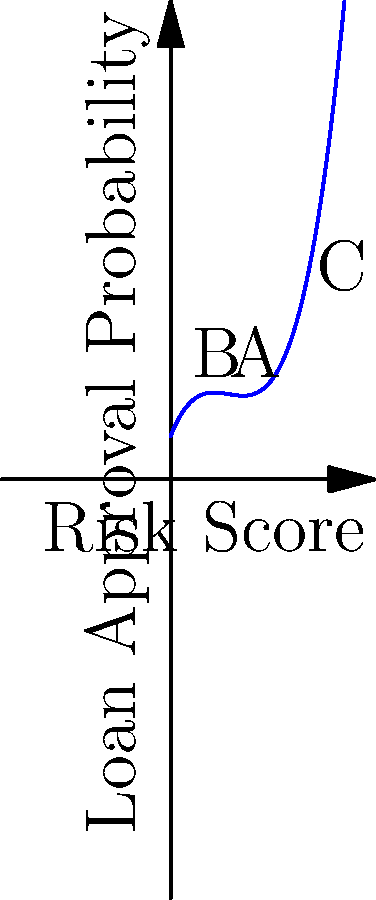As a project manager implementing a new loan risk assessment system, you're analyzing a polynomial graph representing the relationship between risk scores and loan approval probabilities. The graph is defined by the function $f(x) = 0.5x^3 - 2x^2 + 2.5x + 1$, where $x$ is the risk score and $f(x)$ is the loan approval probability. At which point (A, B, or C) does the graph indicate the highest rate of change in approval probability with respect to risk score? To determine the point with the highest rate of change, we need to analyze the derivative of the function at each point. The derivative represents the instantaneous rate of change.

Step 1: Find the derivative of $f(x)$.
$f'(x) = 1.5x^2 - 4x + 2.5$

Step 2: Calculate the derivative at each point:
Point A (x = 1): $f'(1) = 1.5(1)^2 - 4(1) + 2.5 = 0$
Point B (x = 2): $f'(2) = 1.5(2)^2 - 4(2) + 2.5 = 2.5$
Point C (x = 3): $f'(3) = 1.5(3)^2 - 4(3) + 2.5 = 8$

Step 3: Compare the absolute values of the derivatives:
|f'(1)| = 0
|f'(2)| = 2.5
|f'(3)| = 8

Step 4: Identify the point with the highest absolute value of the derivative.
Point C has the highest absolute value, indicating the steepest slope and thus the highest rate of change.
Answer: C 